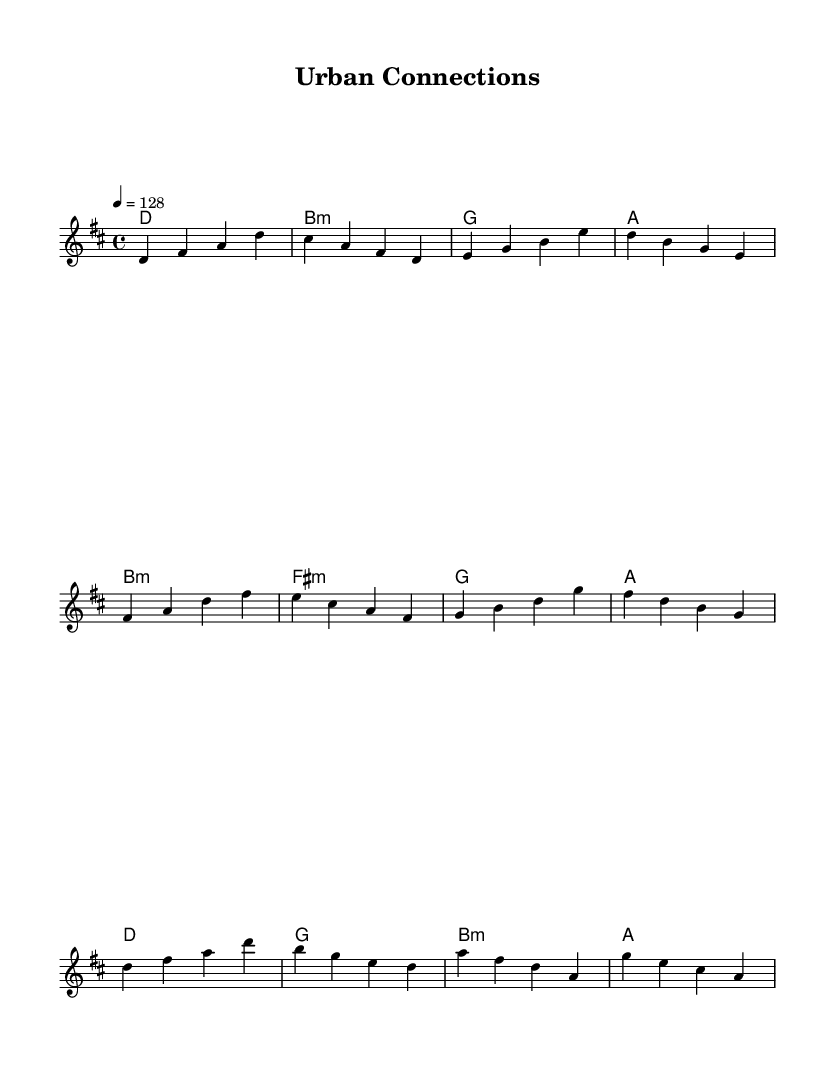What is the key signature of this music? The key signature is indicated at the beginning of the score with a single sharp, which corresponds to D major.
Answer: D major What is the time signature of this piece? The time signature is displayed at the beginning of the score as 4/4, indicating four beats in a measure.
Answer: 4/4 What is the tempo marking given for this piece? The tempo marking is stated as 4 = 128, showing that there are 128 beats per minute, which is a moderate tempo suitable for K-Pop.
Answer: 128 How many measures are in the verse section? Counting the measures in the verse, there are 4 measures, as seen from the melody line presented.
Answer: 4 Which chords are used in the pre-chorus section? The chords in the pre-chorus section are identified in sequence as B minor, F sharp minor, G major, and A major from the harmonies block.
Answer: B minor, F sharp minor, G, A What type of harmony is primarily used in this piece? The harmony primarily consists of simple triads and seventh chords commonly found in K-Pop, providing a rich yet easy-to-follow chord progression.
Answer: Triads What section of the music does the chorus begin? The chorus begins after the pre-chorus, indicated by the shift in melody and the repeating pattern of D major at its start in the score.
Answer: Chorus 